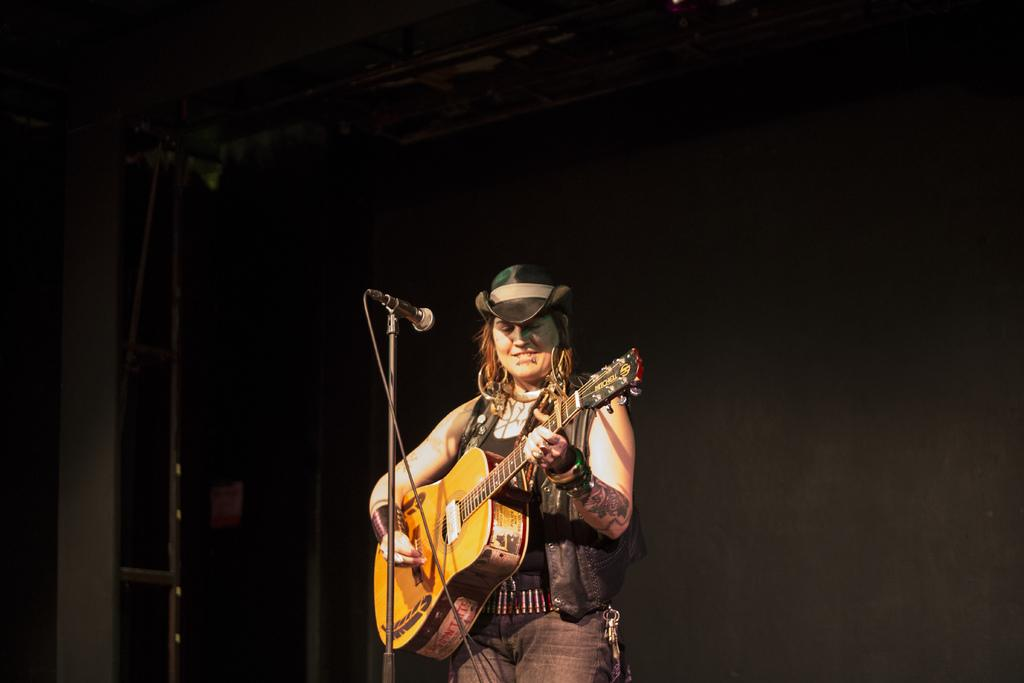What is the main subject of the image? There is a person in the image. What is the person wearing? The person is wearing a hat. What is the person holding? The person is holding a guitar. What is the person standing in front of? The person is standing in front of a mic. How many muscles can be seen flexing in the person's arms in the image? There is no indication of visible muscles flexing in the person's arms in the image. What type of cars are parked behind the person in the image? There are no cars visible in the image; it only features the person, their hat, guitar, and the mic. 